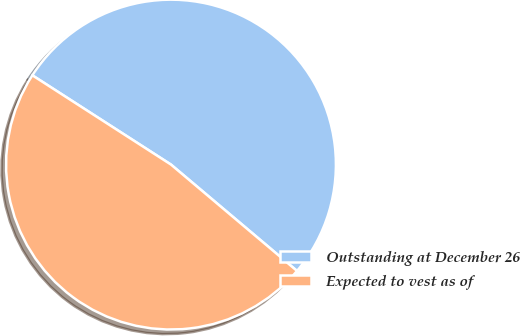Convert chart to OTSL. <chart><loc_0><loc_0><loc_500><loc_500><pie_chart><fcel>Outstanding at December 26<fcel>Expected to vest as of<nl><fcel>52.05%<fcel>47.95%<nl></chart> 